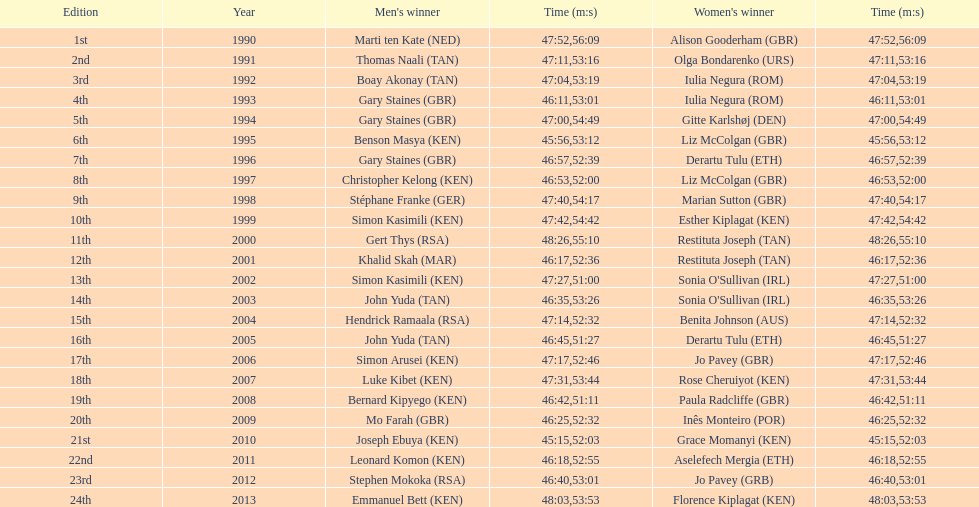How many instances did a single nation achieve victory in both the men's and women's bupa great south run? 4. 